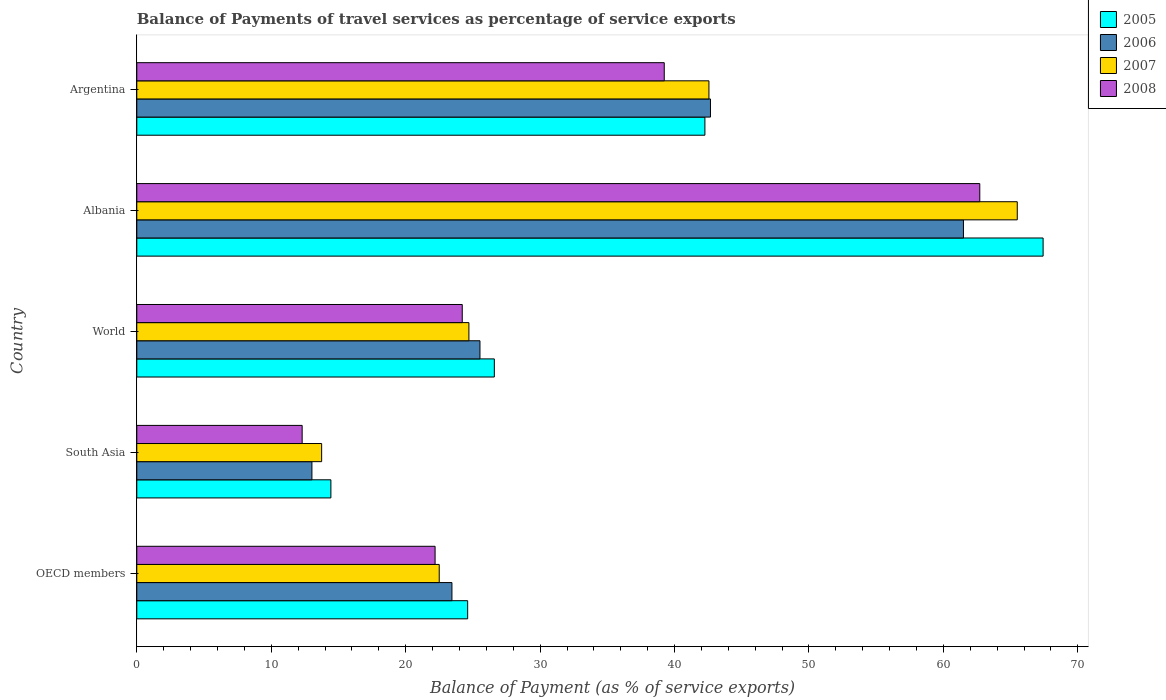How many groups of bars are there?
Offer a terse response. 5. Are the number of bars on each tick of the Y-axis equal?
Offer a very short reply. Yes. How many bars are there on the 2nd tick from the bottom?
Make the answer very short. 4. What is the label of the 1st group of bars from the top?
Offer a very short reply. Argentina. What is the balance of payments of travel services in 2008 in OECD members?
Provide a succinct answer. 22.19. Across all countries, what is the maximum balance of payments of travel services in 2006?
Give a very brief answer. 61.49. Across all countries, what is the minimum balance of payments of travel services in 2005?
Ensure brevity in your answer.  14.44. In which country was the balance of payments of travel services in 2005 maximum?
Offer a terse response. Albania. What is the total balance of payments of travel services in 2005 in the graph?
Your response must be concise. 175.32. What is the difference between the balance of payments of travel services in 2005 in Albania and that in South Asia?
Your answer should be very brief. 52.98. What is the difference between the balance of payments of travel services in 2005 in South Asia and the balance of payments of travel services in 2007 in World?
Your answer should be very brief. -10.27. What is the average balance of payments of travel services in 2005 per country?
Your response must be concise. 35.06. What is the difference between the balance of payments of travel services in 2005 and balance of payments of travel services in 2008 in South Asia?
Give a very brief answer. 2.14. What is the ratio of the balance of payments of travel services in 2007 in Albania to that in OECD members?
Keep it short and to the point. 2.91. What is the difference between the highest and the second highest balance of payments of travel services in 2007?
Make the answer very short. 22.93. What is the difference between the highest and the lowest balance of payments of travel services in 2007?
Provide a succinct answer. 51.74. What does the 4th bar from the top in Argentina represents?
Provide a short and direct response. 2005. Are all the bars in the graph horizontal?
Your answer should be compact. Yes. Are the values on the major ticks of X-axis written in scientific E-notation?
Give a very brief answer. No. Does the graph contain grids?
Your answer should be very brief. No. Where does the legend appear in the graph?
Ensure brevity in your answer.  Top right. What is the title of the graph?
Offer a very short reply. Balance of Payments of travel services as percentage of service exports. Does "1980" appear as one of the legend labels in the graph?
Your response must be concise. No. What is the label or title of the X-axis?
Your answer should be very brief. Balance of Payment (as % of service exports). What is the label or title of the Y-axis?
Ensure brevity in your answer.  Country. What is the Balance of Payment (as % of service exports) of 2005 in OECD members?
Provide a succinct answer. 24.61. What is the Balance of Payment (as % of service exports) of 2006 in OECD members?
Keep it short and to the point. 23.44. What is the Balance of Payment (as % of service exports) of 2007 in OECD members?
Your answer should be very brief. 22.5. What is the Balance of Payment (as % of service exports) of 2008 in OECD members?
Your response must be concise. 22.19. What is the Balance of Payment (as % of service exports) of 2005 in South Asia?
Offer a very short reply. 14.44. What is the Balance of Payment (as % of service exports) of 2006 in South Asia?
Your response must be concise. 13.03. What is the Balance of Payment (as % of service exports) of 2007 in South Asia?
Ensure brevity in your answer.  13.75. What is the Balance of Payment (as % of service exports) of 2008 in South Asia?
Give a very brief answer. 12.3. What is the Balance of Payment (as % of service exports) in 2005 in World?
Give a very brief answer. 26.59. What is the Balance of Payment (as % of service exports) in 2006 in World?
Give a very brief answer. 25.53. What is the Balance of Payment (as % of service exports) in 2007 in World?
Give a very brief answer. 24.7. What is the Balance of Payment (as % of service exports) of 2008 in World?
Your answer should be compact. 24.21. What is the Balance of Payment (as % of service exports) in 2005 in Albania?
Provide a short and direct response. 67.42. What is the Balance of Payment (as % of service exports) of 2006 in Albania?
Your answer should be compact. 61.49. What is the Balance of Payment (as % of service exports) in 2007 in Albania?
Provide a short and direct response. 65.49. What is the Balance of Payment (as % of service exports) of 2008 in Albania?
Your answer should be compact. 62.7. What is the Balance of Payment (as % of service exports) in 2005 in Argentina?
Provide a short and direct response. 42.26. What is the Balance of Payment (as % of service exports) of 2006 in Argentina?
Make the answer very short. 42.67. What is the Balance of Payment (as % of service exports) of 2007 in Argentina?
Ensure brevity in your answer.  42.56. What is the Balance of Payment (as % of service exports) in 2008 in Argentina?
Offer a terse response. 39.23. Across all countries, what is the maximum Balance of Payment (as % of service exports) in 2005?
Ensure brevity in your answer.  67.42. Across all countries, what is the maximum Balance of Payment (as % of service exports) in 2006?
Your answer should be compact. 61.49. Across all countries, what is the maximum Balance of Payment (as % of service exports) of 2007?
Offer a very short reply. 65.49. Across all countries, what is the maximum Balance of Payment (as % of service exports) in 2008?
Your answer should be compact. 62.7. Across all countries, what is the minimum Balance of Payment (as % of service exports) of 2005?
Your answer should be compact. 14.44. Across all countries, what is the minimum Balance of Payment (as % of service exports) of 2006?
Your answer should be compact. 13.03. Across all countries, what is the minimum Balance of Payment (as % of service exports) in 2007?
Offer a very short reply. 13.75. Across all countries, what is the minimum Balance of Payment (as % of service exports) of 2008?
Offer a very short reply. 12.3. What is the total Balance of Payment (as % of service exports) in 2005 in the graph?
Your answer should be compact. 175.32. What is the total Balance of Payment (as % of service exports) in 2006 in the graph?
Your response must be concise. 166.16. What is the total Balance of Payment (as % of service exports) in 2007 in the graph?
Offer a very short reply. 169. What is the total Balance of Payment (as % of service exports) in 2008 in the graph?
Give a very brief answer. 160.64. What is the difference between the Balance of Payment (as % of service exports) of 2005 in OECD members and that in South Asia?
Offer a very short reply. 10.17. What is the difference between the Balance of Payment (as % of service exports) of 2006 in OECD members and that in South Asia?
Offer a very short reply. 10.41. What is the difference between the Balance of Payment (as % of service exports) in 2007 in OECD members and that in South Asia?
Your response must be concise. 8.75. What is the difference between the Balance of Payment (as % of service exports) in 2008 in OECD members and that in South Asia?
Your answer should be very brief. 9.89. What is the difference between the Balance of Payment (as % of service exports) of 2005 in OECD members and that in World?
Your answer should be compact. -1.98. What is the difference between the Balance of Payment (as % of service exports) of 2006 in OECD members and that in World?
Offer a terse response. -2.09. What is the difference between the Balance of Payment (as % of service exports) in 2007 in OECD members and that in World?
Give a very brief answer. -2.21. What is the difference between the Balance of Payment (as % of service exports) in 2008 in OECD members and that in World?
Your response must be concise. -2.02. What is the difference between the Balance of Payment (as % of service exports) in 2005 in OECD members and that in Albania?
Your response must be concise. -42.8. What is the difference between the Balance of Payment (as % of service exports) in 2006 in OECD members and that in Albania?
Keep it short and to the point. -38.05. What is the difference between the Balance of Payment (as % of service exports) of 2007 in OECD members and that in Albania?
Your answer should be very brief. -43. What is the difference between the Balance of Payment (as % of service exports) in 2008 in OECD members and that in Albania?
Provide a short and direct response. -40.52. What is the difference between the Balance of Payment (as % of service exports) of 2005 in OECD members and that in Argentina?
Provide a succinct answer. -17.65. What is the difference between the Balance of Payment (as % of service exports) of 2006 in OECD members and that in Argentina?
Provide a short and direct response. -19.23. What is the difference between the Balance of Payment (as % of service exports) of 2007 in OECD members and that in Argentina?
Provide a succinct answer. -20.06. What is the difference between the Balance of Payment (as % of service exports) of 2008 in OECD members and that in Argentina?
Offer a terse response. -17.05. What is the difference between the Balance of Payment (as % of service exports) in 2005 in South Asia and that in World?
Your answer should be compact. -12.16. What is the difference between the Balance of Payment (as % of service exports) in 2006 in South Asia and that in World?
Your answer should be very brief. -12.5. What is the difference between the Balance of Payment (as % of service exports) in 2007 in South Asia and that in World?
Ensure brevity in your answer.  -10.95. What is the difference between the Balance of Payment (as % of service exports) of 2008 in South Asia and that in World?
Offer a terse response. -11.91. What is the difference between the Balance of Payment (as % of service exports) in 2005 in South Asia and that in Albania?
Make the answer very short. -52.98. What is the difference between the Balance of Payment (as % of service exports) of 2006 in South Asia and that in Albania?
Offer a very short reply. -48.46. What is the difference between the Balance of Payment (as % of service exports) in 2007 in South Asia and that in Albania?
Your response must be concise. -51.74. What is the difference between the Balance of Payment (as % of service exports) in 2008 in South Asia and that in Albania?
Keep it short and to the point. -50.4. What is the difference between the Balance of Payment (as % of service exports) in 2005 in South Asia and that in Argentina?
Your response must be concise. -27.82. What is the difference between the Balance of Payment (as % of service exports) in 2006 in South Asia and that in Argentina?
Keep it short and to the point. -29.64. What is the difference between the Balance of Payment (as % of service exports) in 2007 in South Asia and that in Argentina?
Offer a very short reply. -28.81. What is the difference between the Balance of Payment (as % of service exports) of 2008 in South Asia and that in Argentina?
Your response must be concise. -26.93. What is the difference between the Balance of Payment (as % of service exports) in 2005 in World and that in Albania?
Your answer should be compact. -40.82. What is the difference between the Balance of Payment (as % of service exports) of 2006 in World and that in Albania?
Provide a succinct answer. -35.96. What is the difference between the Balance of Payment (as % of service exports) in 2007 in World and that in Albania?
Provide a succinct answer. -40.79. What is the difference between the Balance of Payment (as % of service exports) in 2008 in World and that in Albania?
Provide a succinct answer. -38.5. What is the difference between the Balance of Payment (as % of service exports) in 2005 in World and that in Argentina?
Ensure brevity in your answer.  -15.66. What is the difference between the Balance of Payment (as % of service exports) in 2006 in World and that in Argentina?
Ensure brevity in your answer.  -17.15. What is the difference between the Balance of Payment (as % of service exports) of 2007 in World and that in Argentina?
Give a very brief answer. -17.85. What is the difference between the Balance of Payment (as % of service exports) in 2008 in World and that in Argentina?
Keep it short and to the point. -15.03. What is the difference between the Balance of Payment (as % of service exports) of 2005 in Albania and that in Argentina?
Provide a short and direct response. 25.16. What is the difference between the Balance of Payment (as % of service exports) in 2006 in Albania and that in Argentina?
Your answer should be very brief. 18.82. What is the difference between the Balance of Payment (as % of service exports) in 2007 in Albania and that in Argentina?
Give a very brief answer. 22.93. What is the difference between the Balance of Payment (as % of service exports) of 2008 in Albania and that in Argentina?
Make the answer very short. 23.47. What is the difference between the Balance of Payment (as % of service exports) in 2005 in OECD members and the Balance of Payment (as % of service exports) in 2006 in South Asia?
Your answer should be compact. 11.58. What is the difference between the Balance of Payment (as % of service exports) in 2005 in OECD members and the Balance of Payment (as % of service exports) in 2007 in South Asia?
Ensure brevity in your answer.  10.86. What is the difference between the Balance of Payment (as % of service exports) of 2005 in OECD members and the Balance of Payment (as % of service exports) of 2008 in South Asia?
Offer a very short reply. 12.31. What is the difference between the Balance of Payment (as % of service exports) of 2006 in OECD members and the Balance of Payment (as % of service exports) of 2007 in South Asia?
Offer a very short reply. 9.69. What is the difference between the Balance of Payment (as % of service exports) in 2006 in OECD members and the Balance of Payment (as % of service exports) in 2008 in South Asia?
Your response must be concise. 11.14. What is the difference between the Balance of Payment (as % of service exports) in 2007 in OECD members and the Balance of Payment (as % of service exports) in 2008 in South Asia?
Your answer should be very brief. 10.19. What is the difference between the Balance of Payment (as % of service exports) in 2005 in OECD members and the Balance of Payment (as % of service exports) in 2006 in World?
Your response must be concise. -0.92. What is the difference between the Balance of Payment (as % of service exports) of 2005 in OECD members and the Balance of Payment (as % of service exports) of 2007 in World?
Give a very brief answer. -0.09. What is the difference between the Balance of Payment (as % of service exports) in 2005 in OECD members and the Balance of Payment (as % of service exports) in 2008 in World?
Your answer should be compact. 0.4. What is the difference between the Balance of Payment (as % of service exports) in 2006 in OECD members and the Balance of Payment (as % of service exports) in 2007 in World?
Your answer should be very brief. -1.26. What is the difference between the Balance of Payment (as % of service exports) of 2006 in OECD members and the Balance of Payment (as % of service exports) of 2008 in World?
Make the answer very short. -0.77. What is the difference between the Balance of Payment (as % of service exports) in 2007 in OECD members and the Balance of Payment (as % of service exports) in 2008 in World?
Offer a very short reply. -1.71. What is the difference between the Balance of Payment (as % of service exports) in 2005 in OECD members and the Balance of Payment (as % of service exports) in 2006 in Albania?
Keep it short and to the point. -36.88. What is the difference between the Balance of Payment (as % of service exports) of 2005 in OECD members and the Balance of Payment (as % of service exports) of 2007 in Albania?
Provide a short and direct response. -40.88. What is the difference between the Balance of Payment (as % of service exports) of 2005 in OECD members and the Balance of Payment (as % of service exports) of 2008 in Albania?
Your response must be concise. -38.09. What is the difference between the Balance of Payment (as % of service exports) of 2006 in OECD members and the Balance of Payment (as % of service exports) of 2007 in Albania?
Your answer should be compact. -42.05. What is the difference between the Balance of Payment (as % of service exports) of 2006 in OECD members and the Balance of Payment (as % of service exports) of 2008 in Albania?
Your response must be concise. -39.26. What is the difference between the Balance of Payment (as % of service exports) in 2007 in OECD members and the Balance of Payment (as % of service exports) in 2008 in Albania?
Provide a short and direct response. -40.21. What is the difference between the Balance of Payment (as % of service exports) in 2005 in OECD members and the Balance of Payment (as % of service exports) in 2006 in Argentina?
Offer a very short reply. -18.06. What is the difference between the Balance of Payment (as % of service exports) of 2005 in OECD members and the Balance of Payment (as % of service exports) of 2007 in Argentina?
Offer a terse response. -17.95. What is the difference between the Balance of Payment (as % of service exports) in 2005 in OECD members and the Balance of Payment (as % of service exports) in 2008 in Argentina?
Make the answer very short. -14.62. What is the difference between the Balance of Payment (as % of service exports) of 2006 in OECD members and the Balance of Payment (as % of service exports) of 2007 in Argentina?
Offer a very short reply. -19.12. What is the difference between the Balance of Payment (as % of service exports) of 2006 in OECD members and the Balance of Payment (as % of service exports) of 2008 in Argentina?
Offer a very short reply. -15.79. What is the difference between the Balance of Payment (as % of service exports) of 2007 in OECD members and the Balance of Payment (as % of service exports) of 2008 in Argentina?
Offer a terse response. -16.74. What is the difference between the Balance of Payment (as % of service exports) of 2005 in South Asia and the Balance of Payment (as % of service exports) of 2006 in World?
Your response must be concise. -11.09. What is the difference between the Balance of Payment (as % of service exports) of 2005 in South Asia and the Balance of Payment (as % of service exports) of 2007 in World?
Provide a short and direct response. -10.27. What is the difference between the Balance of Payment (as % of service exports) in 2005 in South Asia and the Balance of Payment (as % of service exports) in 2008 in World?
Provide a short and direct response. -9.77. What is the difference between the Balance of Payment (as % of service exports) in 2006 in South Asia and the Balance of Payment (as % of service exports) in 2007 in World?
Your answer should be compact. -11.68. What is the difference between the Balance of Payment (as % of service exports) of 2006 in South Asia and the Balance of Payment (as % of service exports) of 2008 in World?
Your response must be concise. -11.18. What is the difference between the Balance of Payment (as % of service exports) in 2007 in South Asia and the Balance of Payment (as % of service exports) in 2008 in World?
Ensure brevity in your answer.  -10.46. What is the difference between the Balance of Payment (as % of service exports) of 2005 in South Asia and the Balance of Payment (as % of service exports) of 2006 in Albania?
Keep it short and to the point. -47.05. What is the difference between the Balance of Payment (as % of service exports) in 2005 in South Asia and the Balance of Payment (as % of service exports) in 2007 in Albania?
Provide a succinct answer. -51.05. What is the difference between the Balance of Payment (as % of service exports) in 2005 in South Asia and the Balance of Payment (as % of service exports) in 2008 in Albania?
Your answer should be compact. -48.27. What is the difference between the Balance of Payment (as % of service exports) in 2006 in South Asia and the Balance of Payment (as % of service exports) in 2007 in Albania?
Your response must be concise. -52.47. What is the difference between the Balance of Payment (as % of service exports) in 2006 in South Asia and the Balance of Payment (as % of service exports) in 2008 in Albania?
Provide a short and direct response. -49.68. What is the difference between the Balance of Payment (as % of service exports) in 2007 in South Asia and the Balance of Payment (as % of service exports) in 2008 in Albania?
Ensure brevity in your answer.  -48.95. What is the difference between the Balance of Payment (as % of service exports) of 2005 in South Asia and the Balance of Payment (as % of service exports) of 2006 in Argentina?
Your answer should be very brief. -28.23. What is the difference between the Balance of Payment (as % of service exports) of 2005 in South Asia and the Balance of Payment (as % of service exports) of 2007 in Argentina?
Provide a succinct answer. -28.12. What is the difference between the Balance of Payment (as % of service exports) in 2005 in South Asia and the Balance of Payment (as % of service exports) in 2008 in Argentina?
Provide a short and direct response. -24.8. What is the difference between the Balance of Payment (as % of service exports) of 2006 in South Asia and the Balance of Payment (as % of service exports) of 2007 in Argentina?
Your response must be concise. -29.53. What is the difference between the Balance of Payment (as % of service exports) of 2006 in South Asia and the Balance of Payment (as % of service exports) of 2008 in Argentina?
Provide a short and direct response. -26.21. What is the difference between the Balance of Payment (as % of service exports) in 2007 in South Asia and the Balance of Payment (as % of service exports) in 2008 in Argentina?
Your answer should be compact. -25.48. What is the difference between the Balance of Payment (as % of service exports) of 2005 in World and the Balance of Payment (as % of service exports) of 2006 in Albania?
Offer a terse response. -34.9. What is the difference between the Balance of Payment (as % of service exports) in 2005 in World and the Balance of Payment (as % of service exports) in 2007 in Albania?
Your response must be concise. -38.9. What is the difference between the Balance of Payment (as % of service exports) in 2005 in World and the Balance of Payment (as % of service exports) in 2008 in Albania?
Offer a very short reply. -36.11. What is the difference between the Balance of Payment (as % of service exports) of 2006 in World and the Balance of Payment (as % of service exports) of 2007 in Albania?
Your response must be concise. -39.97. What is the difference between the Balance of Payment (as % of service exports) in 2006 in World and the Balance of Payment (as % of service exports) in 2008 in Albania?
Ensure brevity in your answer.  -37.18. What is the difference between the Balance of Payment (as % of service exports) of 2007 in World and the Balance of Payment (as % of service exports) of 2008 in Albania?
Your answer should be compact. -38. What is the difference between the Balance of Payment (as % of service exports) in 2005 in World and the Balance of Payment (as % of service exports) in 2006 in Argentina?
Keep it short and to the point. -16.08. What is the difference between the Balance of Payment (as % of service exports) in 2005 in World and the Balance of Payment (as % of service exports) in 2007 in Argentina?
Ensure brevity in your answer.  -15.96. What is the difference between the Balance of Payment (as % of service exports) in 2005 in World and the Balance of Payment (as % of service exports) in 2008 in Argentina?
Give a very brief answer. -12.64. What is the difference between the Balance of Payment (as % of service exports) in 2006 in World and the Balance of Payment (as % of service exports) in 2007 in Argentina?
Provide a succinct answer. -17.03. What is the difference between the Balance of Payment (as % of service exports) of 2006 in World and the Balance of Payment (as % of service exports) of 2008 in Argentina?
Your answer should be compact. -13.71. What is the difference between the Balance of Payment (as % of service exports) in 2007 in World and the Balance of Payment (as % of service exports) in 2008 in Argentina?
Provide a short and direct response. -14.53. What is the difference between the Balance of Payment (as % of service exports) of 2005 in Albania and the Balance of Payment (as % of service exports) of 2006 in Argentina?
Make the answer very short. 24.74. What is the difference between the Balance of Payment (as % of service exports) of 2005 in Albania and the Balance of Payment (as % of service exports) of 2007 in Argentina?
Provide a short and direct response. 24.86. What is the difference between the Balance of Payment (as % of service exports) of 2005 in Albania and the Balance of Payment (as % of service exports) of 2008 in Argentina?
Ensure brevity in your answer.  28.18. What is the difference between the Balance of Payment (as % of service exports) in 2006 in Albania and the Balance of Payment (as % of service exports) in 2007 in Argentina?
Ensure brevity in your answer.  18.93. What is the difference between the Balance of Payment (as % of service exports) in 2006 in Albania and the Balance of Payment (as % of service exports) in 2008 in Argentina?
Your answer should be compact. 22.26. What is the difference between the Balance of Payment (as % of service exports) in 2007 in Albania and the Balance of Payment (as % of service exports) in 2008 in Argentina?
Ensure brevity in your answer.  26.26. What is the average Balance of Payment (as % of service exports) of 2005 per country?
Provide a short and direct response. 35.06. What is the average Balance of Payment (as % of service exports) in 2006 per country?
Offer a terse response. 33.23. What is the average Balance of Payment (as % of service exports) in 2007 per country?
Your answer should be compact. 33.8. What is the average Balance of Payment (as % of service exports) of 2008 per country?
Provide a succinct answer. 32.13. What is the difference between the Balance of Payment (as % of service exports) of 2005 and Balance of Payment (as % of service exports) of 2006 in OECD members?
Your answer should be very brief. 1.17. What is the difference between the Balance of Payment (as % of service exports) in 2005 and Balance of Payment (as % of service exports) in 2007 in OECD members?
Make the answer very short. 2.12. What is the difference between the Balance of Payment (as % of service exports) of 2005 and Balance of Payment (as % of service exports) of 2008 in OECD members?
Offer a very short reply. 2.42. What is the difference between the Balance of Payment (as % of service exports) of 2006 and Balance of Payment (as % of service exports) of 2007 in OECD members?
Ensure brevity in your answer.  0.95. What is the difference between the Balance of Payment (as % of service exports) in 2006 and Balance of Payment (as % of service exports) in 2008 in OECD members?
Offer a very short reply. 1.25. What is the difference between the Balance of Payment (as % of service exports) in 2007 and Balance of Payment (as % of service exports) in 2008 in OECD members?
Make the answer very short. 0.31. What is the difference between the Balance of Payment (as % of service exports) of 2005 and Balance of Payment (as % of service exports) of 2006 in South Asia?
Offer a terse response. 1.41. What is the difference between the Balance of Payment (as % of service exports) of 2005 and Balance of Payment (as % of service exports) of 2007 in South Asia?
Ensure brevity in your answer.  0.69. What is the difference between the Balance of Payment (as % of service exports) of 2005 and Balance of Payment (as % of service exports) of 2008 in South Asia?
Offer a very short reply. 2.14. What is the difference between the Balance of Payment (as % of service exports) in 2006 and Balance of Payment (as % of service exports) in 2007 in South Asia?
Offer a terse response. -0.72. What is the difference between the Balance of Payment (as % of service exports) in 2006 and Balance of Payment (as % of service exports) in 2008 in South Asia?
Your answer should be very brief. 0.73. What is the difference between the Balance of Payment (as % of service exports) of 2007 and Balance of Payment (as % of service exports) of 2008 in South Asia?
Ensure brevity in your answer.  1.45. What is the difference between the Balance of Payment (as % of service exports) of 2005 and Balance of Payment (as % of service exports) of 2006 in World?
Your response must be concise. 1.07. What is the difference between the Balance of Payment (as % of service exports) in 2005 and Balance of Payment (as % of service exports) in 2007 in World?
Your answer should be compact. 1.89. What is the difference between the Balance of Payment (as % of service exports) of 2005 and Balance of Payment (as % of service exports) of 2008 in World?
Your answer should be compact. 2.39. What is the difference between the Balance of Payment (as % of service exports) of 2006 and Balance of Payment (as % of service exports) of 2007 in World?
Your answer should be very brief. 0.82. What is the difference between the Balance of Payment (as % of service exports) in 2006 and Balance of Payment (as % of service exports) in 2008 in World?
Ensure brevity in your answer.  1.32. What is the difference between the Balance of Payment (as % of service exports) in 2007 and Balance of Payment (as % of service exports) in 2008 in World?
Make the answer very short. 0.5. What is the difference between the Balance of Payment (as % of service exports) in 2005 and Balance of Payment (as % of service exports) in 2006 in Albania?
Offer a very short reply. 5.92. What is the difference between the Balance of Payment (as % of service exports) of 2005 and Balance of Payment (as % of service exports) of 2007 in Albania?
Offer a very short reply. 1.92. What is the difference between the Balance of Payment (as % of service exports) in 2005 and Balance of Payment (as % of service exports) in 2008 in Albania?
Make the answer very short. 4.71. What is the difference between the Balance of Payment (as % of service exports) in 2006 and Balance of Payment (as % of service exports) in 2007 in Albania?
Give a very brief answer. -4. What is the difference between the Balance of Payment (as % of service exports) of 2006 and Balance of Payment (as % of service exports) of 2008 in Albania?
Your answer should be compact. -1.21. What is the difference between the Balance of Payment (as % of service exports) of 2007 and Balance of Payment (as % of service exports) of 2008 in Albania?
Offer a terse response. 2.79. What is the difference between the Balance of Payment (as % of service exports) of 2005 and Balance of Payment (as % of service exports) of 2006 in Argentina?
Offer a terse response. -0.41. What is the difference between the Balance of Payment (as % of service exports) of 2005 and Balance of Payment (as % of service exports) of 2007 in Argentina?
Ensure brevity in your answer.  -0.3. What is the difference between the Balance of Payment (as % of service exports) of 2005 and Balance of Payment (as % of service exports) of 2008 in Argentina?
Your answer should be very brief. 3.02. What is the difference between the Balance of Payment (as % of service exports) in 2006 and Balance of Payment (as % of service exports) in 2007 in Argentina?
Provide a short and direct response. 0.11. What is the difference between the Balance of Payment (as % of service exports) in 2006 and Balance of Payment (as % of service exports) in 2008 in Argentina?
Make the answer very short. 3.44. What is the difference between the Balance of Payment (as % of service exports) of 2007 and Balance of Payment (as % of service exports) of 2008 in Argentina?
Your answer should be very brief. 3.32. What is the ratio of the Balance of Payment (as % of service exports) of 2005 in OECD members to that in South Asia?
Provide a short and direct response. 1.7. What is the ratio of the Balance of Payment (as % of service exports) of 2006 in OECD members to that in South Asia?
Provide a succinct answer. 1.8. What is the ratio of the Balance of Payment (as % of service exports) of 2007 in OECD members to that in South Asia?
Your response must be concise. 1.64. What is the ratio of the Balance of Payment (as % of service exports) of 2008 in OECD members to that in South Asia?
Your answer should be compact. 1.8. What is the ratio of the Balance of Payment (as % of service exports) in 2005 in OECD members to that in World?
Your response must be concise. 0.93. What is the ratio of the Balance of Payment (as % of service exports) of 2006 in OECD members to that in World?
Keep it short and to the point. 0.92. What is the ratio of the Balance of Payment (as % of service exports) of 2007 in OECD members to that in World?
Your answer should be compact. 0.91. What is the ratio of the Balance of Payment (as % of service exports) of 2008 in OECD members to that in World?
Give a very brief answer. 0.92. What is the ratio of the Balance of Payment (as % of service exports) in 2005 in OECD members to that in Albania?
Offer a terse response. 0.37. What is the ratio of the Balance of Payment (as % of service exports) in 2006 in OECD members to that in Albania?
Offer a very short reply. 0.38. What is the ratio of the Balance of Payment (as % of service exports) in 2007 in OECD members to that in Albania?
Your response must be concise. 0.34. What is the ratio of the Balance of Payment (as % of service exports) in 2008 in OECD members to that in Albania?
Make the answer very short. 0.35. What is the ratio of the Balance of Payment (as % of service exports) of 2005 in OECD members to that in Argentina?
Your answer should be compact. 0.58. What is the ratio of the Balance of Payment (as % of service exports) of 2006 in OECD members to that in Argentina?
Your answer should be compact. 0.55. What is the ratio of the Balance of Payment (as % of service exports) in 2007 in OECD members to that in Argentina?
Give a very brief answer. 0.53. What is the ratio of the Balance of Payment (as % of service exports) in 2008 in OECD members to that in Argentina?
Make the answer very short. 0.57. What is the ratio of the Balance of Payment (as % of service exports) of 2005 in South Asia to that in World?
Provide a succinct answer. 0.54. What is the ratio of the Balance of Payment (as % of service exports) in 2006 in South Asia to that in World?
Your response must be concise. 0.51. What is the ratio of the Balance of Payment (as % of service exports) of 2007 in South Asia to that in World?
Give a very brief answer. 0.56. What is the ratio of the Balance of Payment (as % of service exports) in 2008 in South Asia to that in World?
Offer a very short reply. 0.51. What is the ratio of the Balance of Payment (as % of service exports) of 2005 in South Asia to that in Albania?
Give a very brief answer. 0.21. What is the ratio of the Balance of Payment (as % of service exports) of 2006 in South Asia to that in Albania?
Keep it short and to the point. 0.21. What is the ratio of the Balance of Payment (as % of service exports) in 2007 in South Asia to that in Albania?
Your response must be concise. 0.21. What is the ratio of the Balance of Payment (as % of service exports) in 2008 in South Asia to that in Albania?
Keep it short and to the point. 0.2. What is the ratio of the Balance of Payment (as % of service exports) of 2005 in South Asia to that in Argentina?
Your answer should be very brief. 0.34. What is the ratio of the Balance of Payment (as % of service exports) of 2006 in South Asia to that in Argentina?
Keep it short and to the point. 0.31. What is the ratio of the Balance of Payment (as % of service exports) in 2007 in South Asia to that in Argentina?
Make the answer very short. 0.32. What is the ratio of the Balance of Payment (as % of service exports) in 2008 in South Asia to that in Argentina?
Give a very brief answer. 0.31. What is the ratio of the Balance of Payment (as % of service exports) of 2005 in World to that in Albania?
Your response must be concise. 0.39. What is the ratio of the Balance of Payment (as % of service exports) in 2006 in World to that in Albania?
Provide a short and direct response. 0.42. What is the ratio of the Balance of Payment (as % of service exports) in 2007 in World to that in Albania?
Your answer should be very brief. 0.38. What is the ratio of the Balance of Payment (as % of service exports) of 2008 in World to that in Albania?
Make the answer very short. 0.39. What is the ratio of the Balance of Payment (as % of service exports) in 2005 in World to that in Argentina?
Offer a terse response. 0.63. What is the ratio of the Balance of Payment (as % of service exports) of 2006 in World to that in Argentina?
Provide a succinct answer. 0.6. What is the ratio of the Balance of Payment (as % of service exports) in 2007 in World to that in Argentina?
Provide a succinct answer. 0.58. What is the ratio of the Balance of Payment (as % of service exports) in 2008 in World to that in Argentina?
Provide a succinct answer. 0.62. What is the ratio of the Balance of Payment (as % of service exports) of 2005 in Albania to that in Argentina?
Provide a succinct answer. 1.6. What is the ratio of the Balance of Payment (as % of service exports) in 2006 in Albania to that in Argentina?
Ensure brevity in your answer.  1.44. What is the ratio of the Balance of Payment (as % of service exports) in 2007 in Albania to that in Argentina?
Offer a terse response. 1.54. What is the ratio of the Balance of Payment (as % of service exports) of 2008 in Albania to that in Argentina?
Your answer should be very brief. 1.6. What is the difference between the highest and the second highest Balance of Payment (as % of service exports) in 2005?
Your response must be concise. 25.16. What is the difference between the highest and the second highest Balance of Payment (as % of service exports) of 2006?
Your answer should be very brief. 18.82. What is the difference between the highest and the second highest Balance of Payment (as % of service exports) of 2007?
Provide a short and direct response. 22.93. What is the difference between the highest and the second highest Balance of Payment (as % of service exports) of 2008?
Your response must be concise. 23.47. What is the difference between the highest and the lowest Balance of Payment (as % of service exports) of 2005?
Offer a terse response. 52.98. What is the difference between the highest and the lowest Balance of Payment (as % of service exports) in 2006?
Make the answer very short. 48.46. What is the difference between the highest and the lowest Balance of Payment (as % of service exports) in 2007?
Provide a short and direct response. 51.74. What is the difference between the highest and the lowest Balance of Payment (as % of service exports) of 2008?
Make the answer very short. 50.4. 